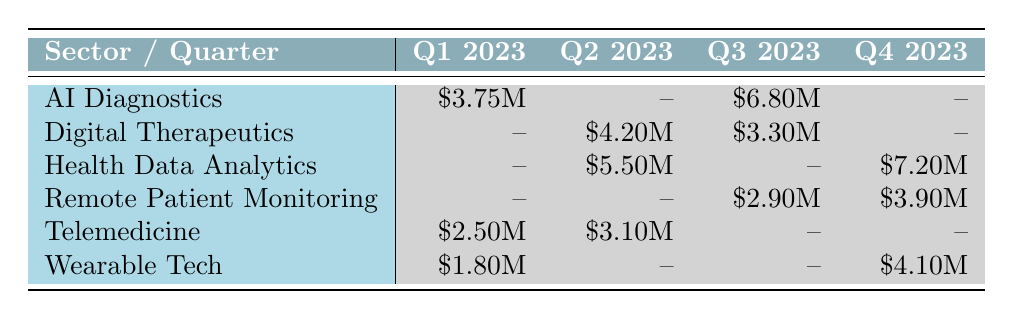What is the total funding amount for AI Diagnostics across all quarters? To find the total funding amount for AI Diagnostics, we check the table for the entries in each quarter. The funding amounts are $3.75M for Q1 2023 and $6.80M for Q3 2023. Adding these amounts gives $3.75M + $6.80M = $10.55M.
Answer: 10.55M Which sector received no funding in Q1 2023? Looking at the table, we see that for Q1 2023, the sectors Telemedicine ($2.50M), AI Diagnostics ($3.75M), and Wearable Tech ($1.80M) received funding. The sectors Digital Therapeutics, Health Data Analytics, and Remote Patient Monitoring did not receive any funding in that quarter.
Answer: Digital Therapeutics, Health Data Analytics, Remote Patient Monitoring What is the highest funding amount received in Q4 2023? We examine the funding amounts for each sector in Q4 2023. The amounts are $4.10M for Wearable Tech, $3.90M for Remote Patient Monitoring, and $7.20M for Health Data Analytics. The highest funding amount is $7.20M (Health Data Analytics).
Answer: 7.20M What is the average funding amount for Telemedicine in the first half of 2023? We find the funding amounts for Telemedicine in Q1 and Q2 2023, which are $2.50M and $3.10M, respectively. To calculate the average, we sum these amounts: $2.50M + $3.10M = $5.60M, and then divide by 2 (the number of quarters): $5.60M / 2 = $2.80M.
Answer: 2.80M Is there any sector that received funding in every quarter of 2023? We check each sector's funding across all quarters. AI Diagnostics received funding in Q1 and Q3; Digital Therapeutics in Q2 and Q3; Health Data Analytics in Q2 and Q4; Remote Patient Monitoring in Q3 and Q4; Telemedicine in Q1 and Q2; and Wearable Tech only in Q1 and Q4. No sector received funding in all four quarters.
Answer: No 